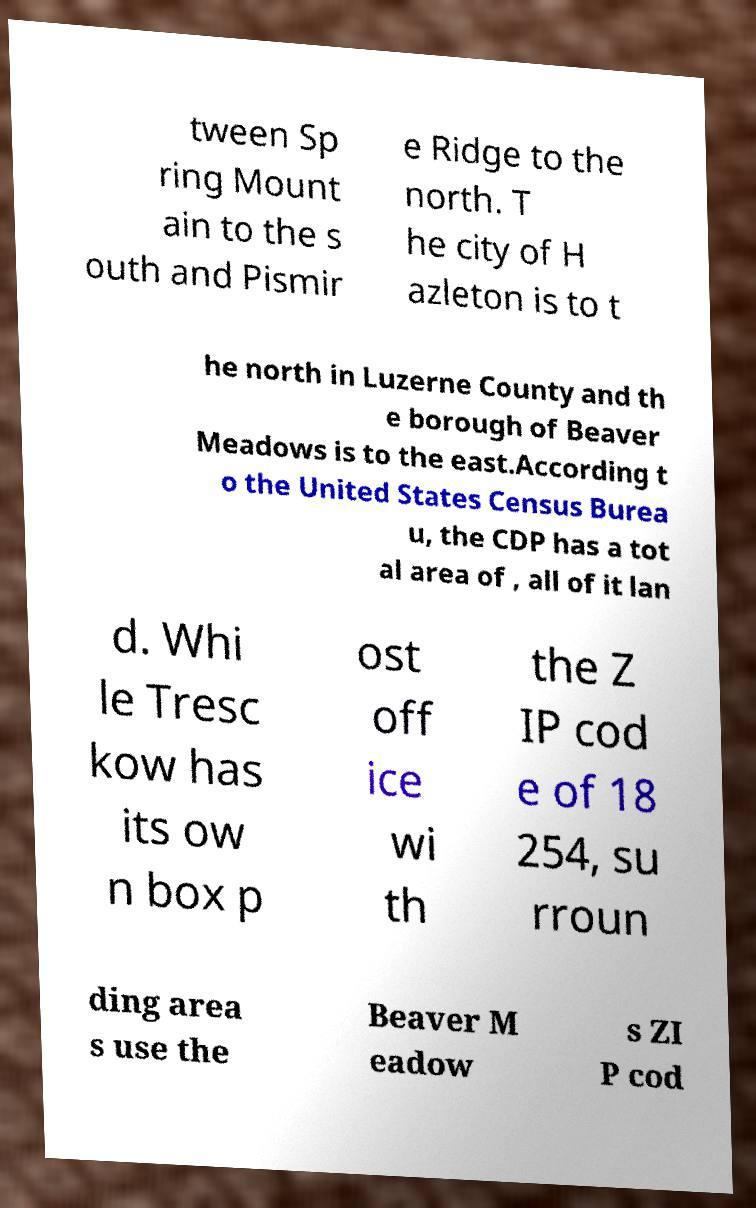Could you extract and type out the text from this image? tween Sp ring Mount ain to the s outh and Pismir e Ridge to the north. T he city of H azleton is to t he north in Luzerne County and th e borough of Beaver Meadows is to the east.According t o the United States Census Burea u, the CDP has a tot al area of , all of it lan d. Whi le Tresc kow has its ow n box p ost off ice wi th the Z IP cod e of 18 254, su rroun ding area s use the Beaver M eadow s ZI P cod 